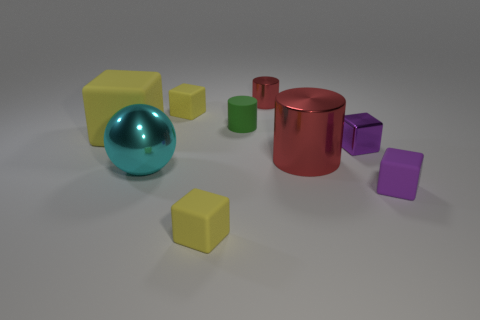How many yellow cubes must be subtracted to get 1 yellow cubes? 2 Subtract all red cylinders. How many cylinders are left? 1 Subtract all cyan cylinders. How many purple blocks are left? 2 Subtract all purple blocks. How many blocks are left? 3 Add 1 tiny gray metal things. How many objects exist? 10 Subtract all cylinders. How many objects are left? 6 Subtract all red cubes. Subtract all purple balls. How many cubes are left? 5 Subtract 0 gray cubes. How many objects are left? 9 Subtract all green matte cylinders. Subtract all rubber things. How many objects are left? 3 Add 9 tiny green rubber cylinders. How many tiny green rubber cylinders are left? 10 